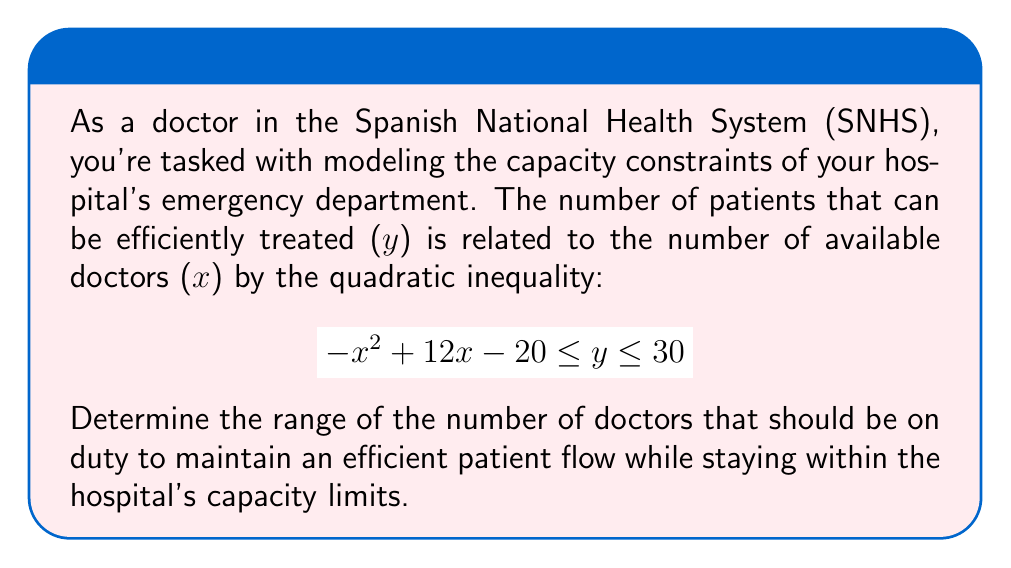Solve this math problem. To solve this problem, we need to consider both the lower and upper bounds of the inequality:

1. Lower bound: $y \geq -x^2 + 12x - 20$
2. Upper bound: $y \leq 30$

We want to find the range of x where these conditions are satisfied simultaneously.

For the lower bound to be less than or equal to the upper bound:

$$ -x^2 + 12x - 20 \leq 30 $$

Rearranging the inequality:

$$ -x^2 + 12x - 50 \leq 0 $$

This is a quadratic inequality. To solve it, we first find the roots of the quadratic equation:

$$ -x^2 + 12x - 50 = 0 $$

Using the quadratic formula, $x = \frac{-b \pm \sqrt{b^2 - 4ac}}{2a}$, where $a=-1$, $b=12$, and $c=-50$:

$$ x = \frac{-12 \pm \sqrt{144 - 4(-1)(-50)}}{2(-1)} = \frac{-12 \pm \sqrt{144 - 200}}{-2} = \frac{-12 \pm \sqrt{-56}}{-2} $$

Since the discriminant is negative, there are no real roots. This means that the parabola of $-x^2 + 12x - 50$ is always above the x-axis.

To find where the inequality is satisfied, we need to determine where the parabola is below or equal to zero. Since the coefficient of $x^2$ is negative, the parabola opens downward, and the inequality is satisfied for all real values of x.

However, in the context of the problem, we need to consider practical constraints:

1. The number of doctors must be positive: $x > 0$
2. The number of doctors must be an integer

Therefore, the range of x is all positive integers: $x \in \{1, 2, 3, ...\}$
Answer: The range of the number of doctors that should be on duty is all positive integers: $x \geq 1$. 